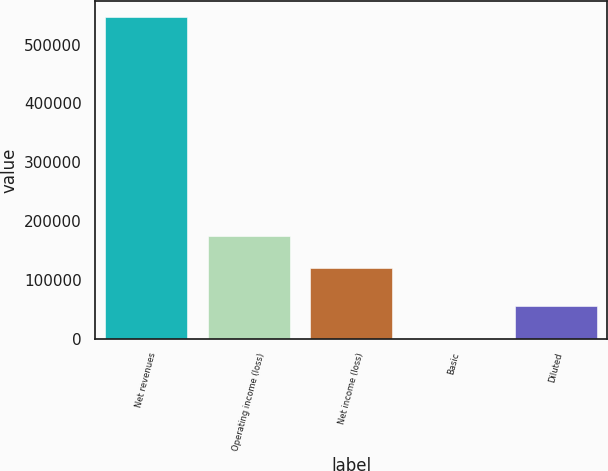<chart> <loc_0><loc_0><loc_500><loc_500><bar_chart><fcel>Net revenues<fcel>Operating income (loss)<fcel>Net income (loss)<fcel>Basic<fcel>Diluted<nl><fcel>546547<fcel>174305<fcel>119650<fcel>0.34<fcel>54655<nl></chart> 